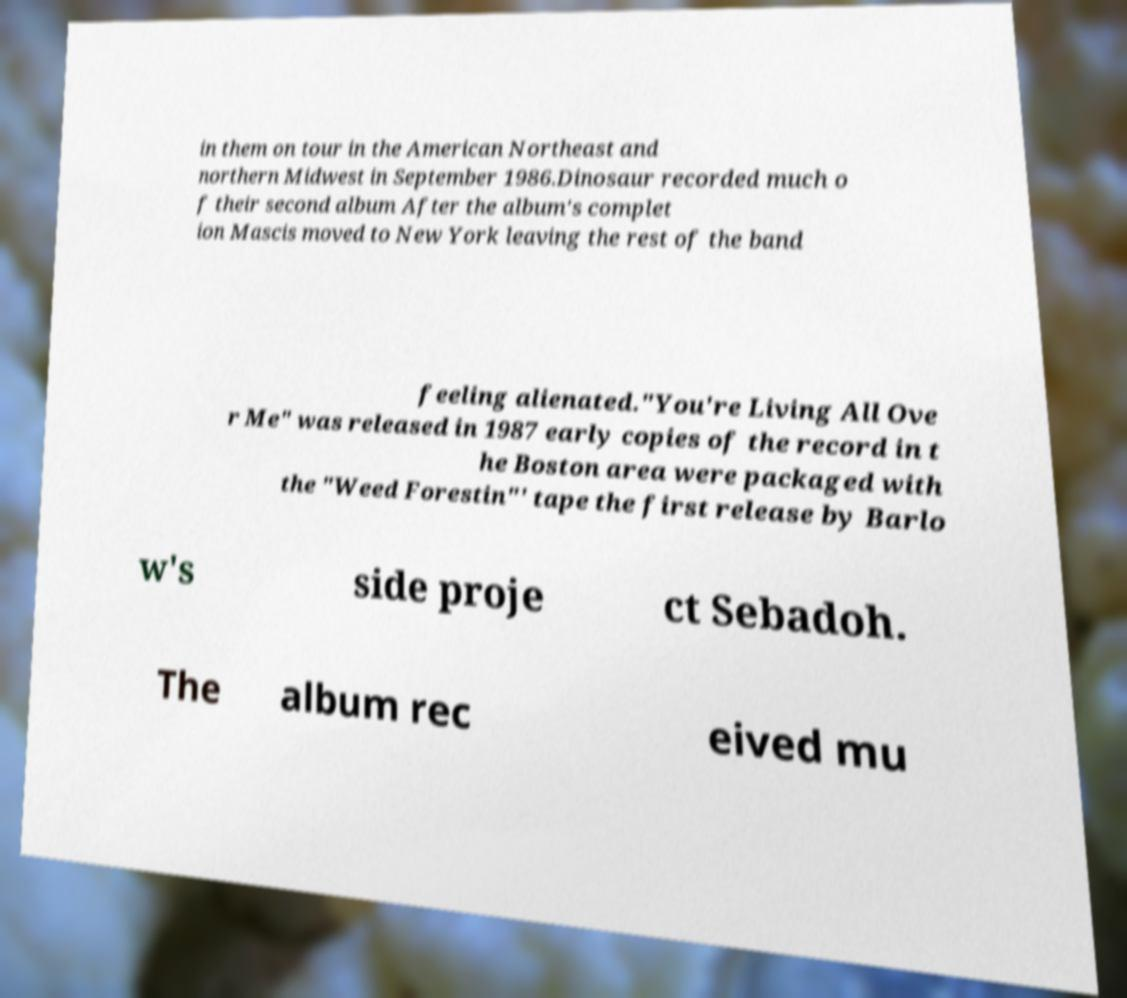Can you read and provide the text displayed in the image?This photo seems to have some interesting text. Can you extract and type it out for me? in them on tour in the American Northeast and northern Midwest in September 1986.Dinosaur recorded much o f their second album After the album's complet ion Mascis moved to New York leaving the rest of the band feeling alienated."You're Living All Ove r Me" was released in 1987 early copies of the record in t he Boston area were packaged with the "Weed Forestin"' tape the first release by Barlo w's side proje ct Sebadoh. The album rec eived mu 